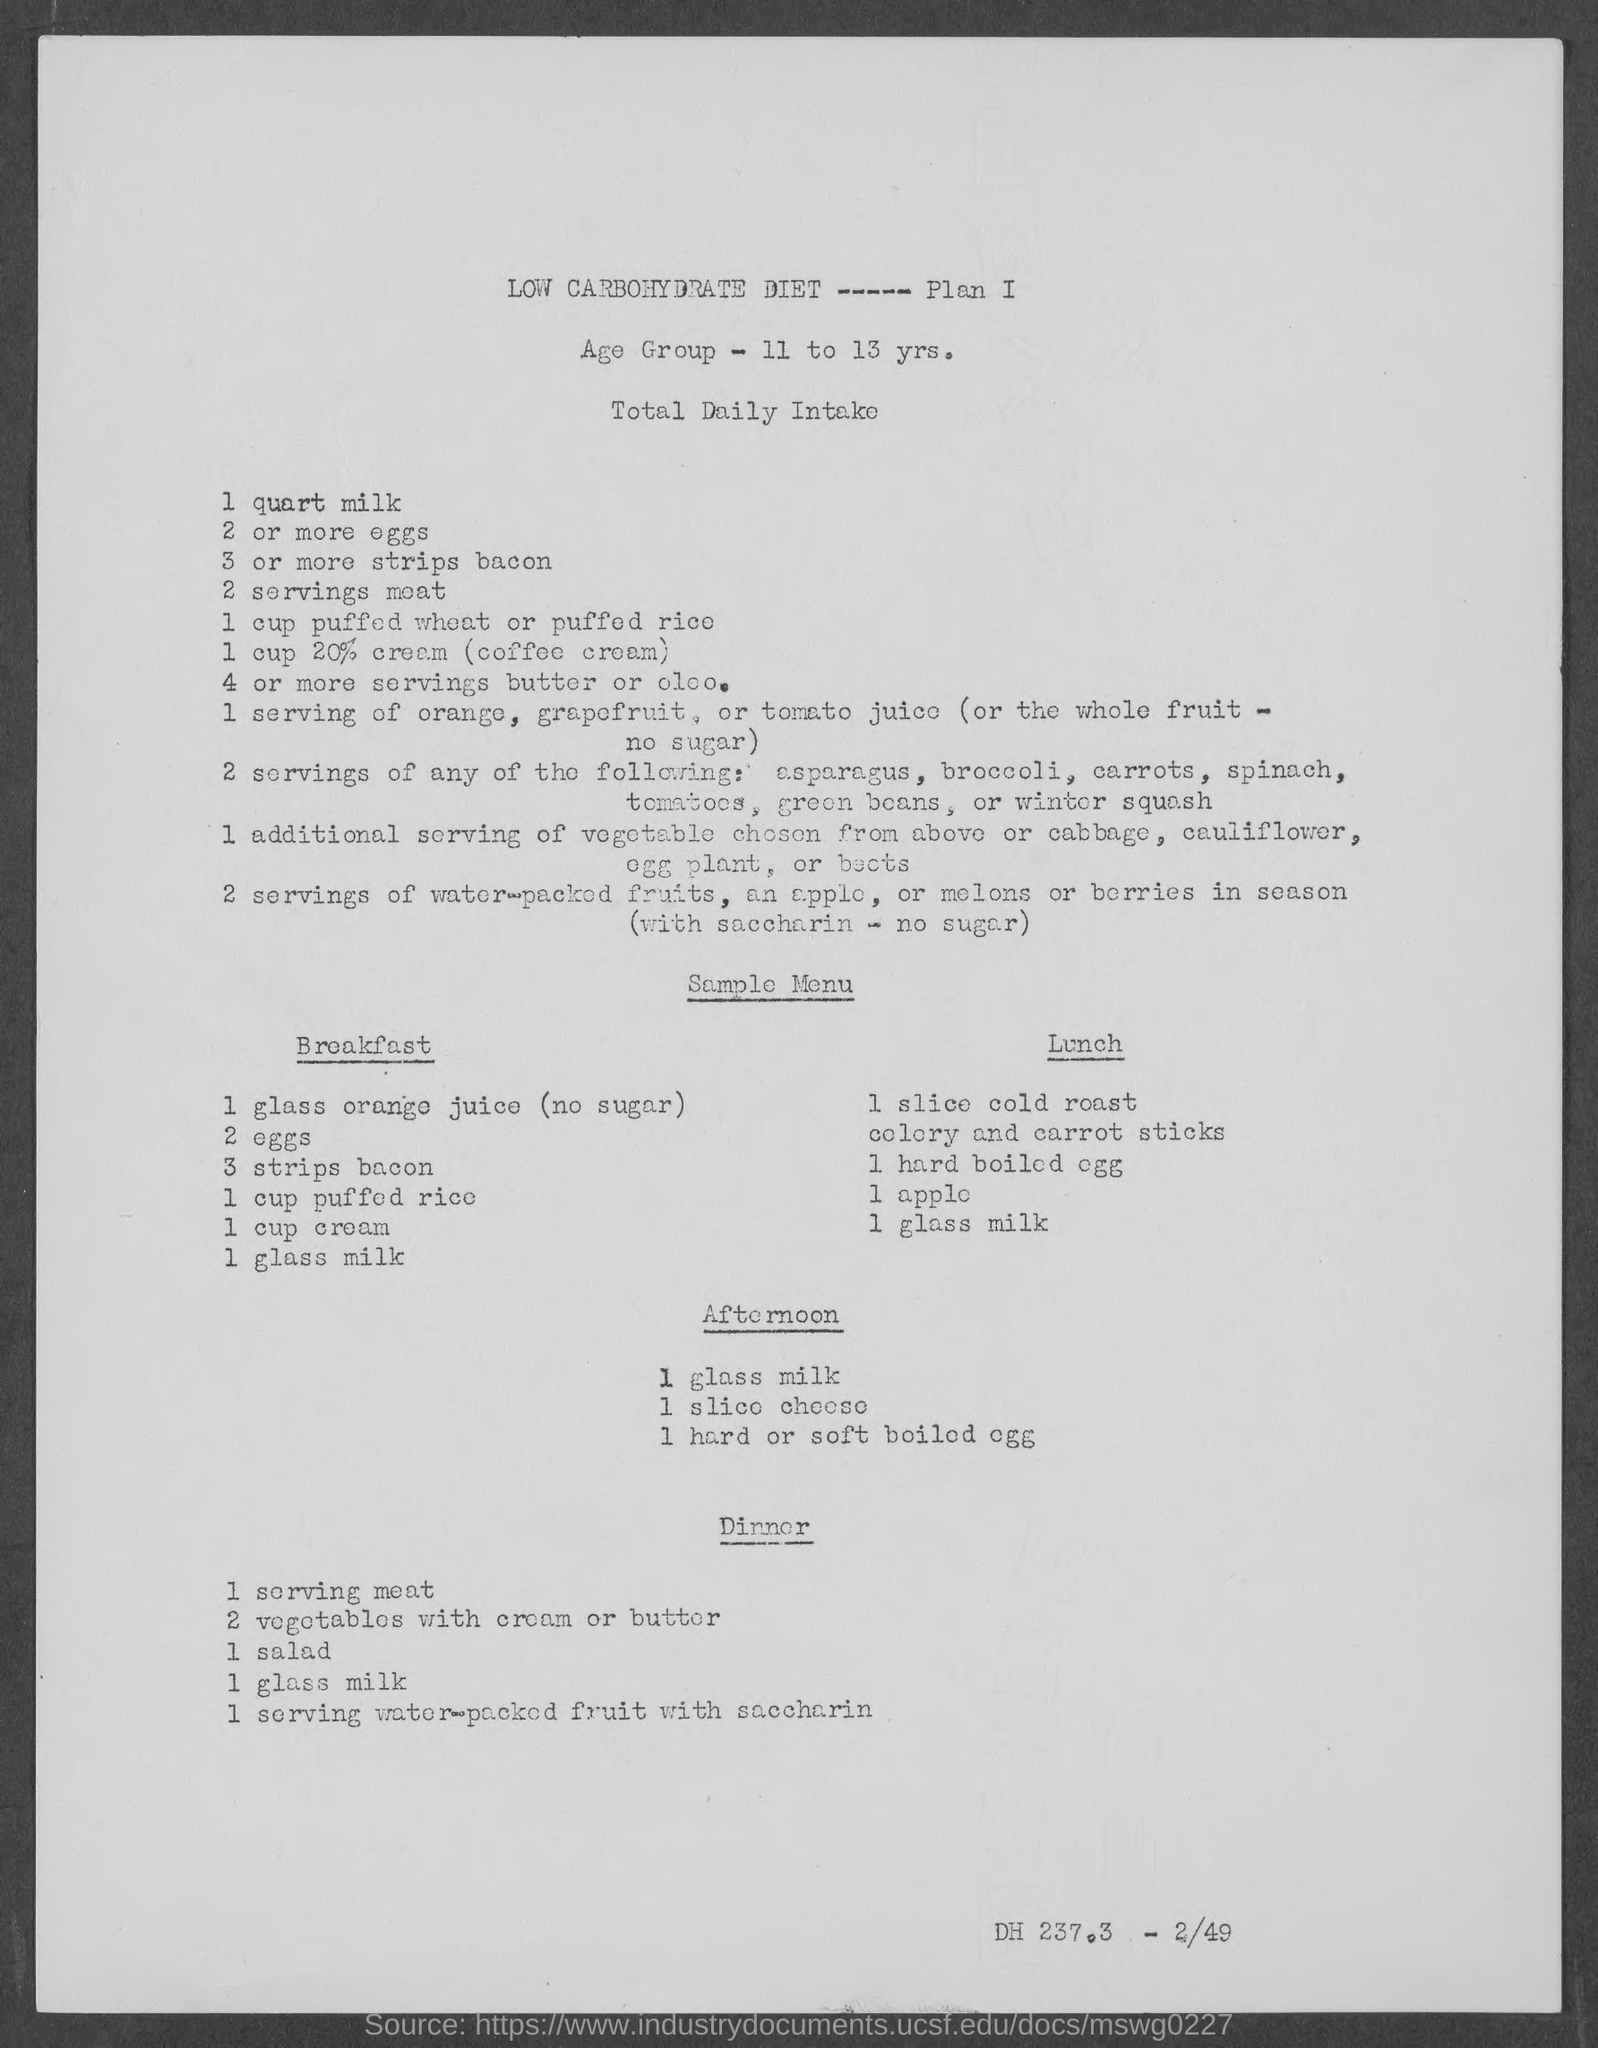Indicate a few pertinent items in this graphic. According to sources, the total daily intake of eggs is two or more. The age group of 11 to 13 years old is... 